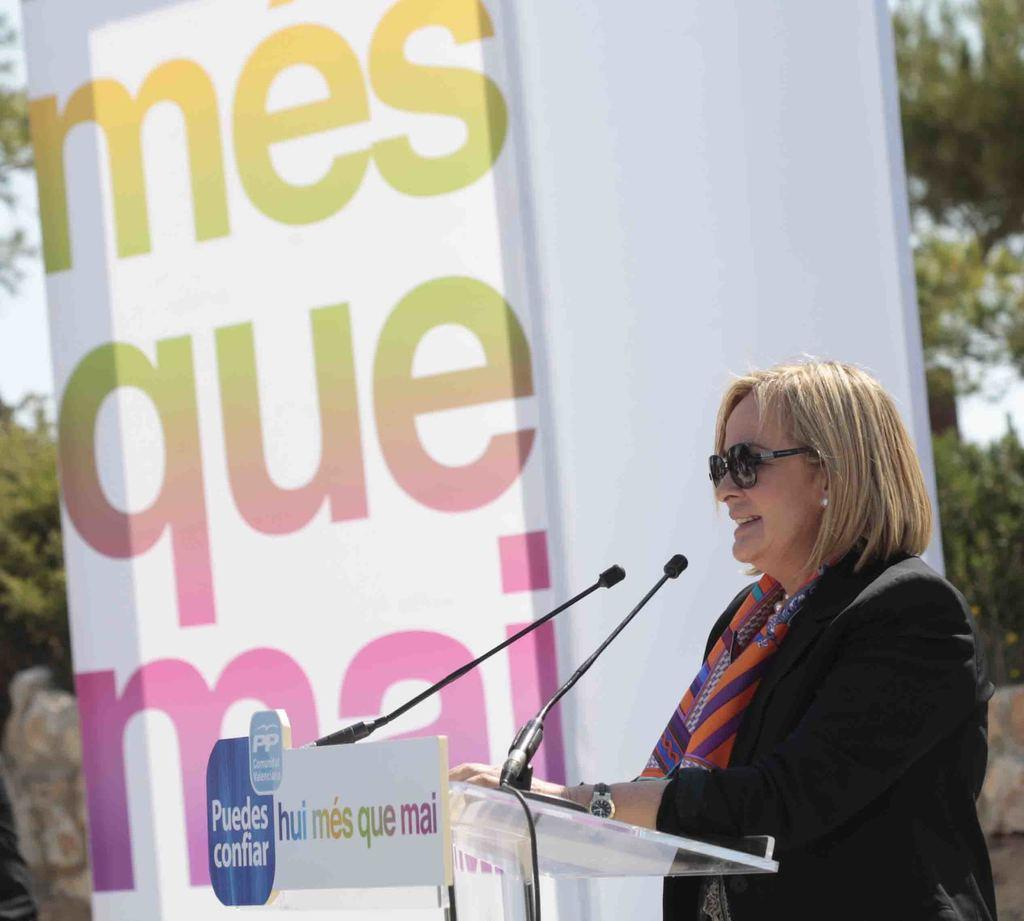What is the main subject of the image? There is a person standing in the image. What objects are present that might be related to the person's activity? There are microphones (mikes) and a podium in the image. What other items can be seen in the image? There are boards in the image. What can be seen in the background of the image? There are trees in the background of the image. What type of unit is being measured by the person in the image? There is no indication in the image that the person is measuring any units. What agreement was reached by the people holding the boards in the image? There are no people holding boards in the image, and no agreements can be determined from the image. 